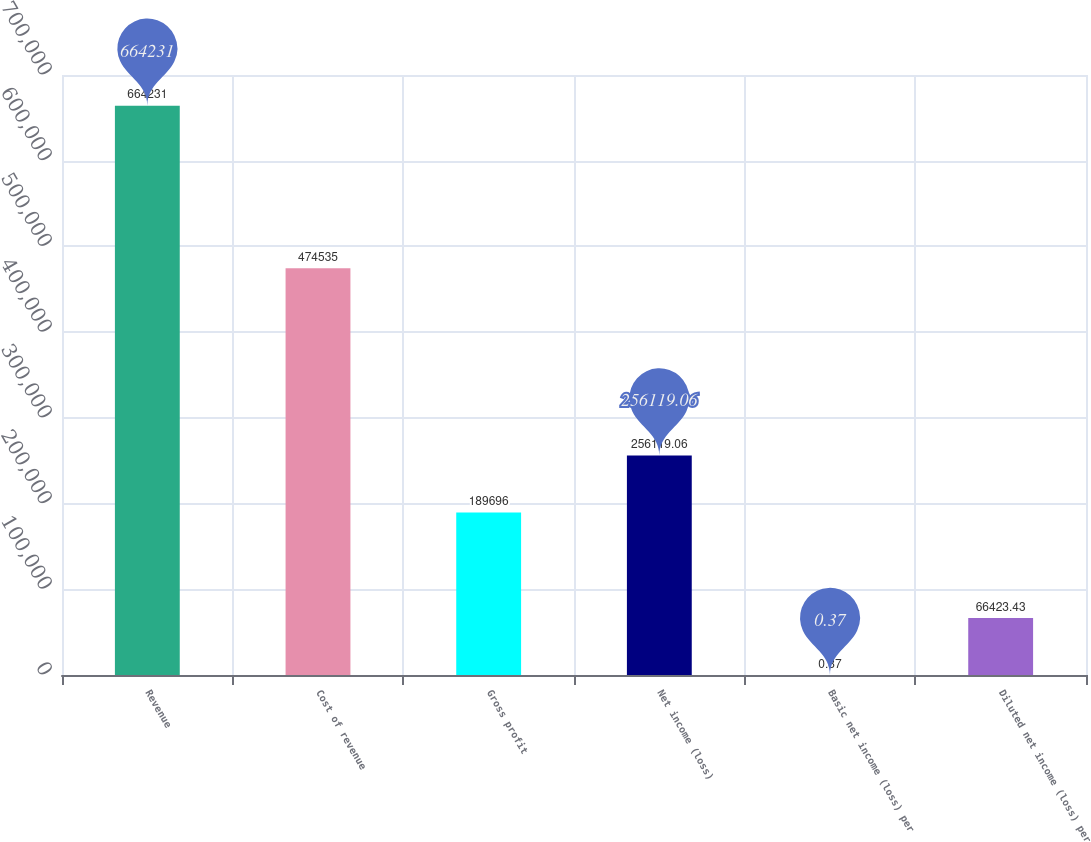Convert chart to OTSL. <chart><loc_0><loc_0><loc_500><loc_500><bar_chart><fcel>Revenue<fcel>Cost of revenue<fcel>Gross profit<fcel>Net income (loss)<fcel>Basic net income (loss) per<fcel>Diluted net income (loss) per<nl><fcel>664231<fcel>474535<fcel>189696<fcel>256119<fcel>0.37<fcel>66423.4<nl></chart> 